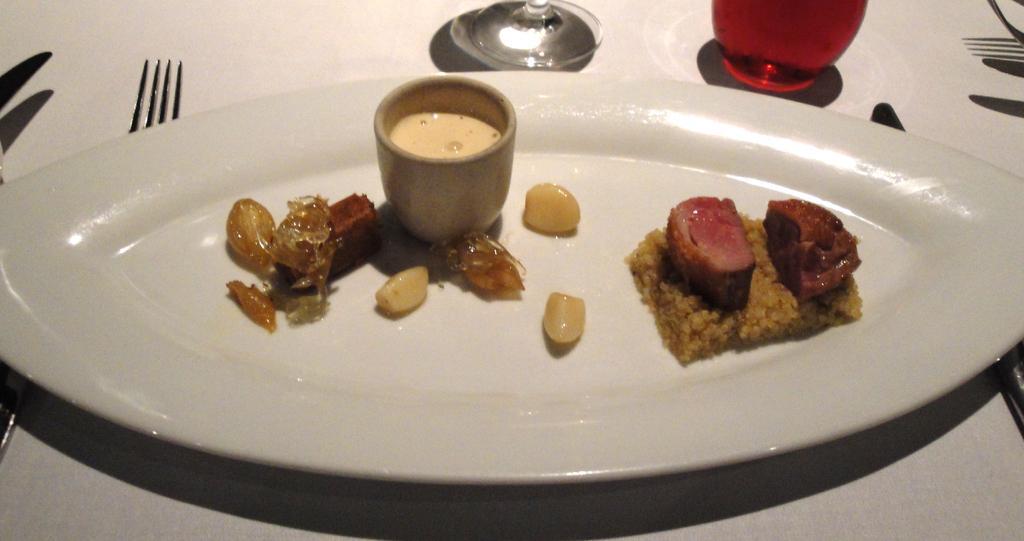Could you give a brief overview of what you see in this image? In this picture there is a tray in the center of the image, which contains food items and a cup of tea, there are glasses at the top side of the image and there are forks and knives on the right and left side of the image. 